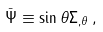Convert formula to latex. <formula><loc_0><loc_0><loc_500><loc_500>\bar { \Psi } \equiv \sin \theta \Sigma _ { , \theta } \, ,</formula> 